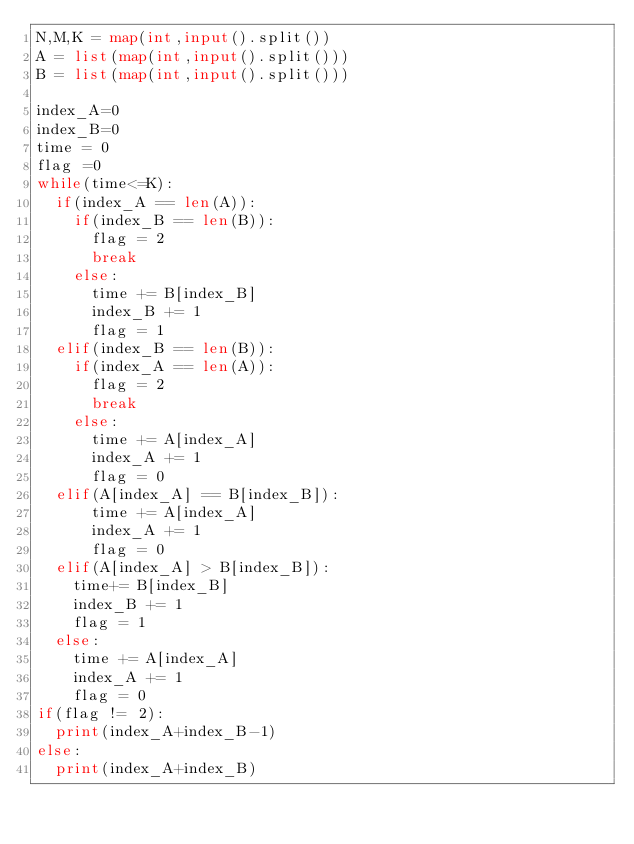Convert code to text. <code><loc_0><loc_0><loc_500><loc_500><_Python_>N,M,K = map(int,input().split())
A = list(map(int,input().split()))
B = list(map(int,input().split()))

index_A=0
index_B=0
time = 0
flag =0
while(time<=K):
  if(index_A == len(A)):
    if(index_B == len(B)):
      flag = 2
      break
    else:
      time += B[index_B]
      index_B += 1
      flag = 1
  elif(index_B == len(B)):
    if(index_A == len(A)):
      flag = 2
      break
    else:
      time += A[index_A]
      index_A += 1
      flag = 0
  elif(A[index_A] == B[index_B]):
      time += A[index_A]
      index_A += 1
      flag = 0
  elif(A[index_A] > B[index_B]):
    time+= B[index_B]
    index_B += 1
    flag = 1
  else: 
    time += A[index_A]
    index_A += 1
    flag = 0
if(flag != 2):
  print(index_A+index_B-1)
else:
  print(index_A+index_B)


</code> 